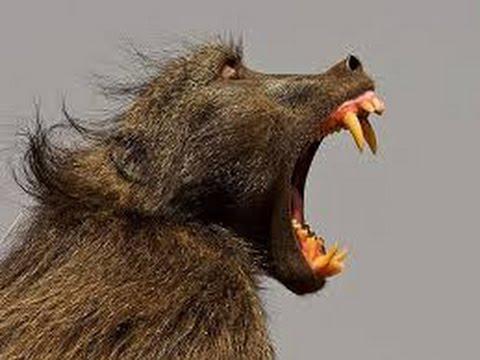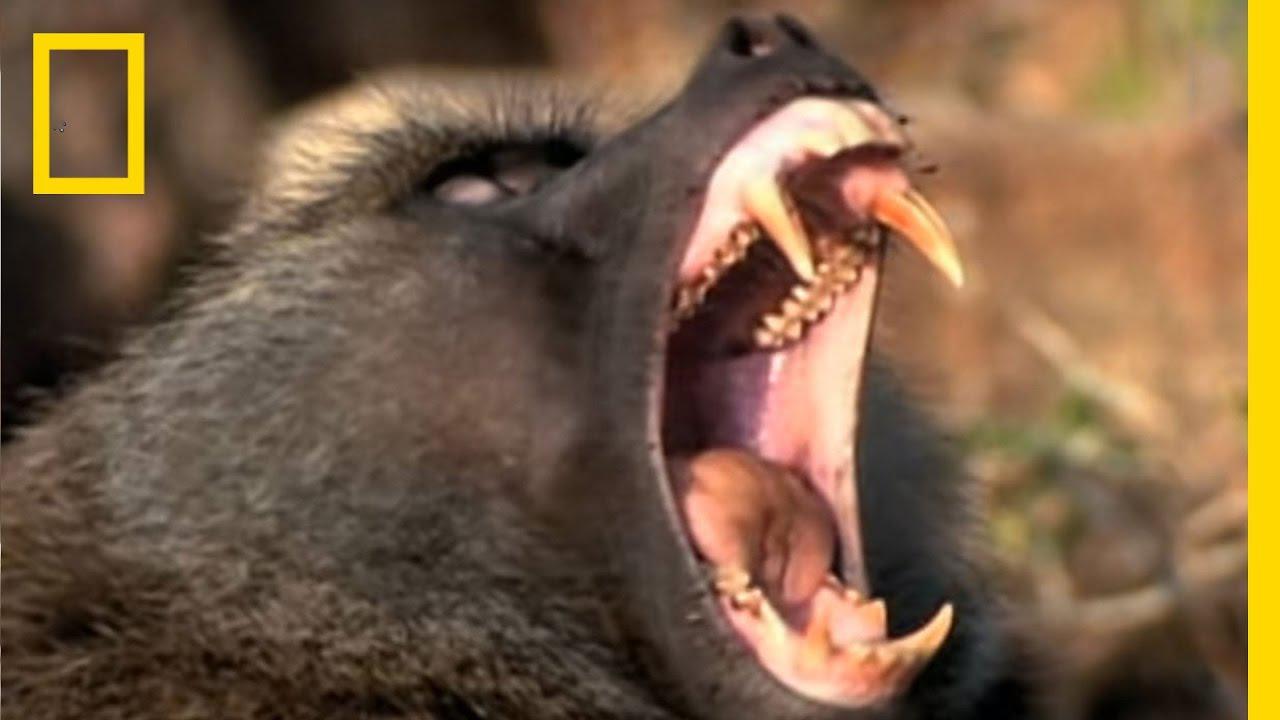The first image is the image on the left, the second image is the image on the right. For the images shown, is this caption "The image on the left contains exactly one animal, and the image on the right is the exact same species and gender as the image on the left." true? Answer yes or no. Yes. The first image is the image on the left, the second image is the image on the right. Given the left and right images, does the statement "There’s a single gray and white baboon with his mouth open looking forward left in the photo." hold true? Answer yes or no. No. 